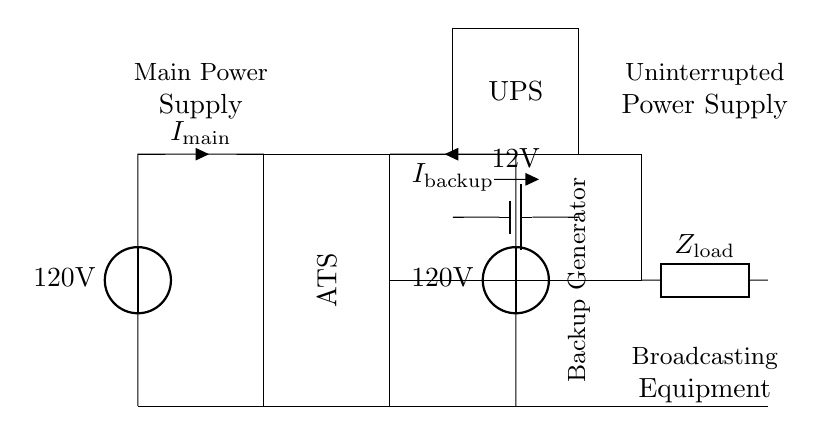What is the main voltage source in the circuit? The main voltage source is labeled as 120 Volts in the circuit diagram. This is indicated by the voltage source symbol at the left side.
Answer: 120 Volts What component ensures an uninterrupted power supply? The component labeled "UPS" in the circuit diagram provides an uninterrupted power supply. It is situated between the main power source and the load.
Answer: UPS What type of switch is used for transferring power in this circuit? The circuit includes an Automatic Transfer Switch (ATS), which is clearly marked within the rectangle between the main power source and the backup generator.
Answer: Automatic Transfer Switch What is the purpose of the backup generator in the circuit? The backup generator provides an alternative 120 Volt power supply when the main power is unavailable, as indicated in the diagram where it connects through the ATS to the load.
Answer: Alternative power supply What is the load connected to the power supply? The load is labeled as "Broadcasting Equipment" in the circuit diagram, represented by the generic symbol at the right side.
Answer: Broadcasting Equipment What is the voltage rating of the battery used in the UPS? The voltage rating of the battery is labeled as 12 Volts in the circuit diagram. This is shown directly above the battery symbol in the UPS section.
Answer: 12 Volts How are the main power supply and backup generator connected to the load? Both the main power supply and backup generator are connected to the load through the Automatic Transfer Switch (ATS), as depicted by the lines that interconnect these components in the circuit.
Answer: Through ATS 